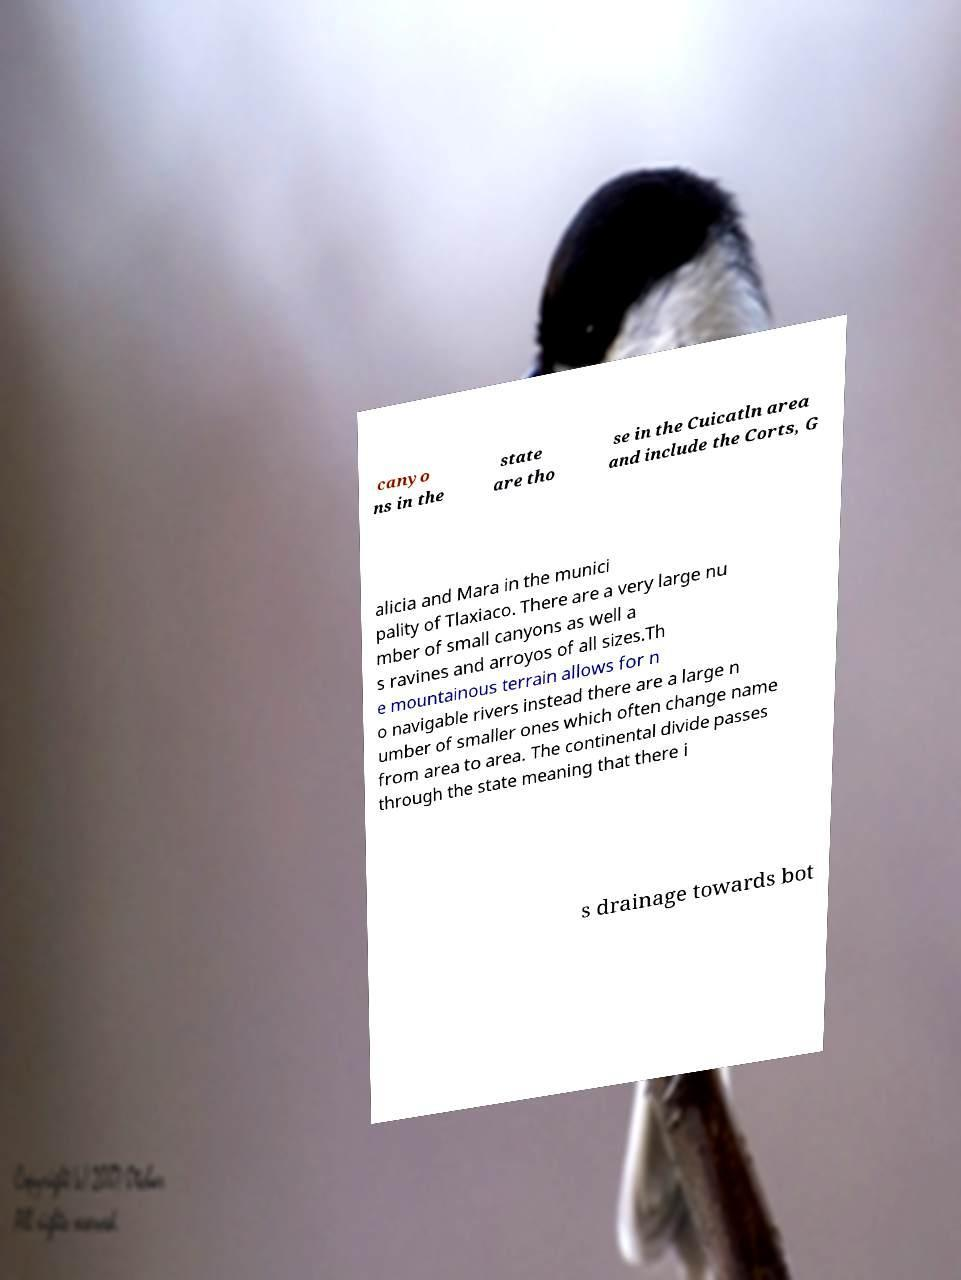There's text embedded in this image that I need extracted. Can you transcribe it verbatim? canyo ns in the state are tho se in the Cuicatln area and include the Corts, G alicia and Mara in the munici pality of Tlaxiaco. There are a very large nu mber of small canyons as well a s ravines and arroyos of all sizes.Th e mountainous terrain allows for n o navigable rivers instead there are a large n umber of smaller ones which often change name from area to area. The continental divide passes through the state meaning that there i s drainage towards bot 